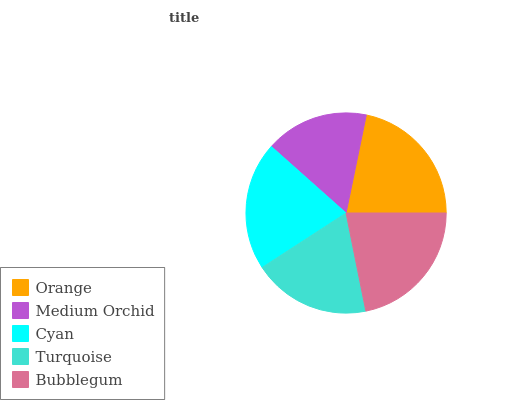Is Medium Orchid the minimum?
Answer yes or no. Yes. Is Bubblegum the maximum?
Answer yes or no. Yes. Is Cyan the minimum?
Answer yes or no. No. Is Cyan the maximum?
Answer yes or no. No. Is Cyan greater than Medium Orchid?
Answer yes or no. Yes. Is Medium Orchid less than Cyan?
Answer yes or no. Yes. Is Medium Orchid greater than Cyan?
Answer yes or no. No. Is Cyan less than Medium Orchid?
Answer yes or no. No. Is Cyan the high median?
Answer yes or no. Yes. Is Cyan the low median?
Answer yes or no. Yes. Is Turquoise the high median?
Answer yes or no. No. Is Turquoise the low median?
Answer yes or no. No. 